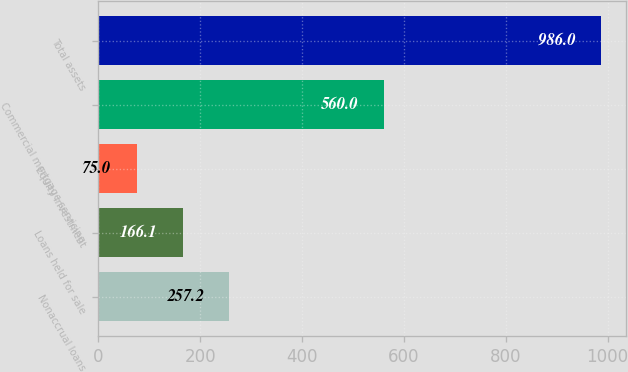Convert chart to OTSL. <chart><loc_0><loc_0><loc_500><loc_500><bar_chart><fcel>Nonaccrual loans<fcel>Loans held for sale<fcel>Equity investment<fcel>Commercial mortgage servicing<fcel>Total assets<nl><fcel>257.2<fcel>166.1<fcel>75<fcel>560<fcel>986<nl></chart> 